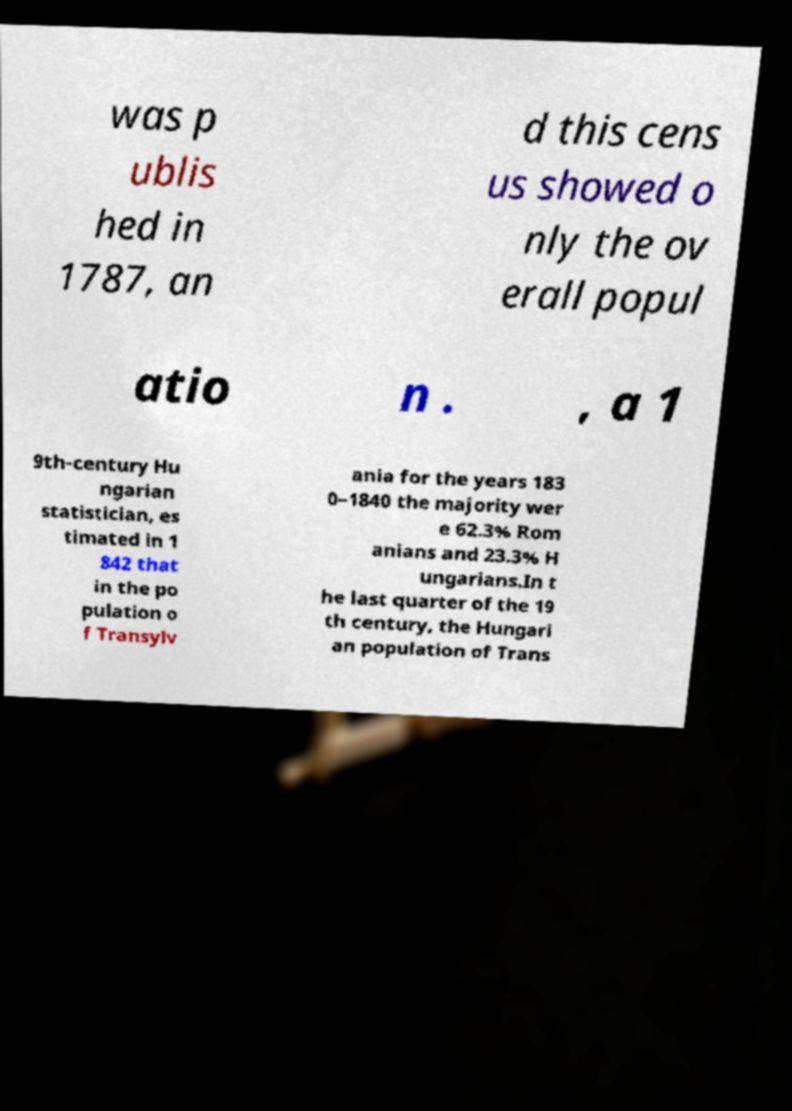There's text embedded in this image that I need extracted. Can you transcribe it verbatim? was p ublis hed in 1787, an d this cens us showed o nly the ov erall popul atio n . , a 1 9th-century Hu ngarian statistician, es timated in 1 842 that in the po pulation o f Transylv ania for the years 183 0–1840 the majority wer e 62.3% Rom anians and 23.3% H ungarians.In t he last quarter of the 19 th century, the Hungari an population of Trans 